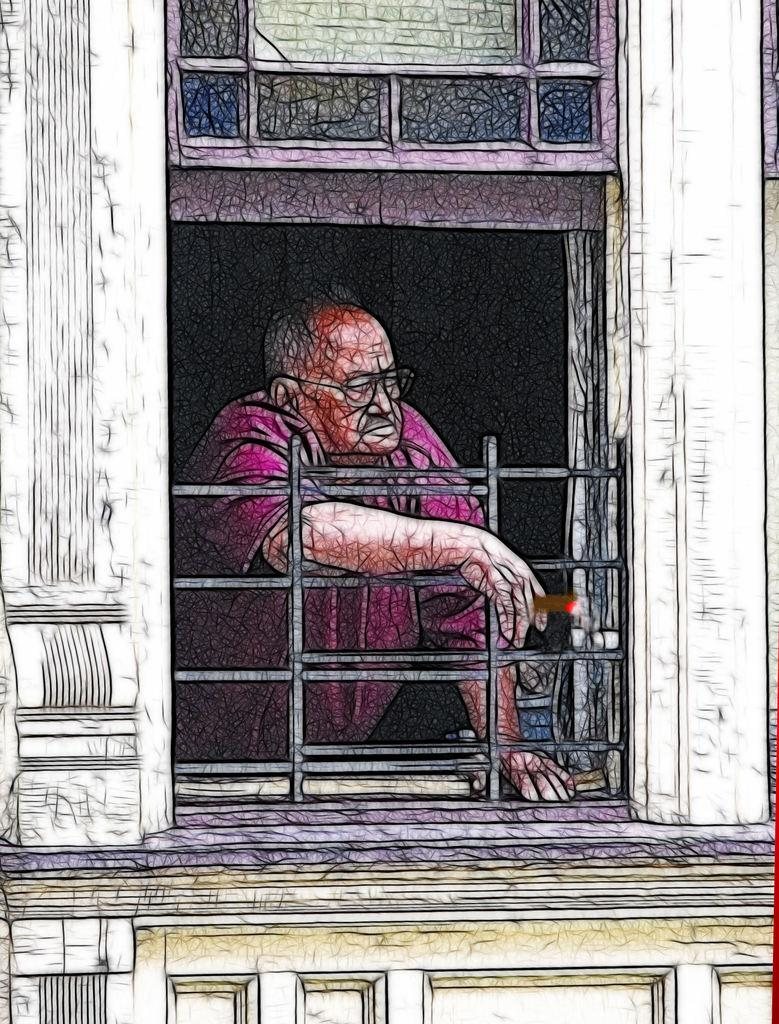What can be said about the nature of the image? The image is edited. Who is present in the image? There is a man in the image. What is the man doing in the image? The man is looking from a window. What is the man wearing on his upper body? The man is wearing a t-shirt. What accessory is the man wearing on his face? The man is wearing spectacles. What type of bun is the man holding in the image? There is no bun present in the image. What is the man using to fuel his curiosity in the image? The man is not depicted as fueling his curiosity in the image. 